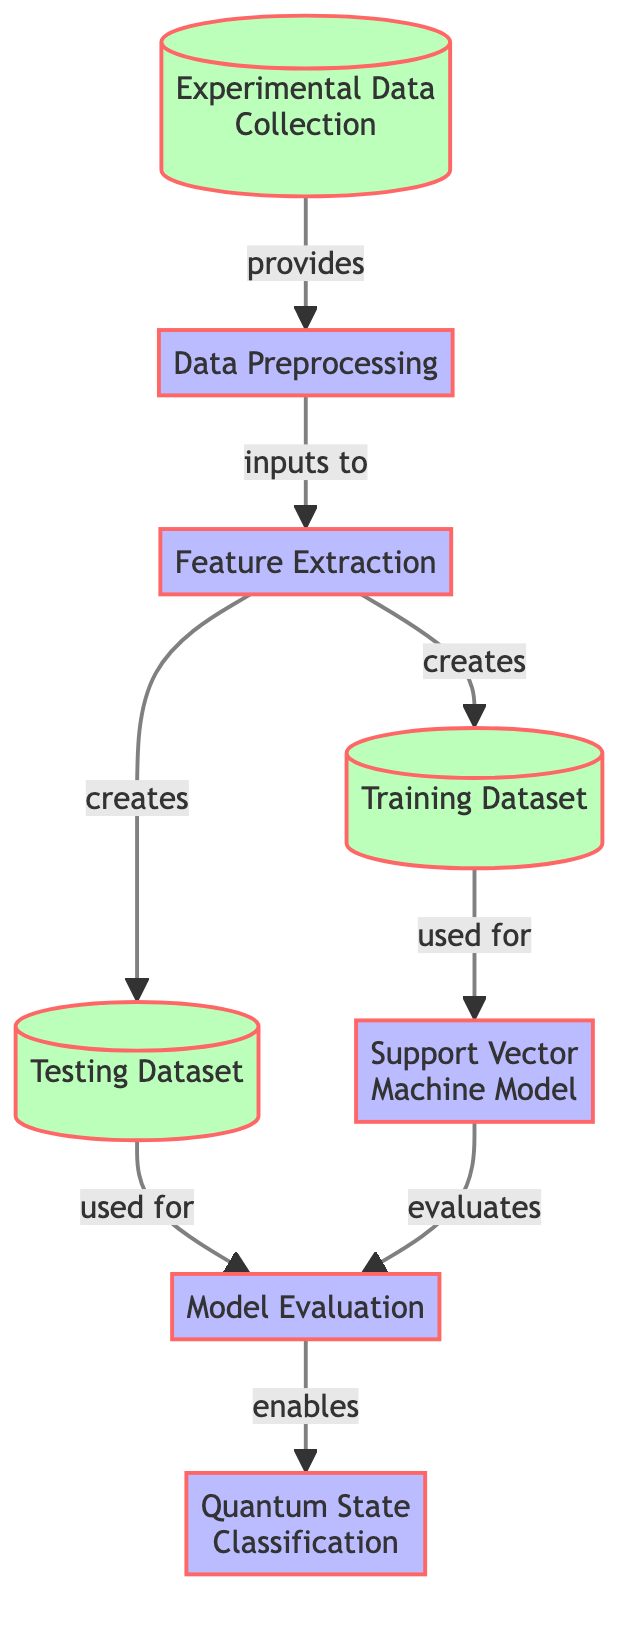What is the first step in the diagram? The first step, or node, in the diagram is "Experimental Data Collection." It is the starting point as indicated by its position at the top of the flowchart.
Answer: Experimental Data Collection How many processes are there in the diagram? By counting the nodes labeled as processes, we find there are four processes: "Data Preprocessing," "Feature Extraction," "Support Vector Machine Model," and "Model Evaluation."
Answer: Four What does the "Feature Extraction" node create? The "Feature Extraction" node has outgoing edges that lead to the "Training Dataset" and "Testing Dataset," indicating that it creates both of these outputs.
Answer: Training Dataset and Testing Dataset What is evaluated in the "Model Evaluation" step? The "Model Evaluation" step evaluates the "Support Vector Machine Model," as shown by the directed edge pointing from the model to the evaluation process.
Answer: Support Vector Machine Model Which node enables the "Quantum State Classification"? The "Model Evaluation" node enables the "Quantum State Classification," as indicated by the directional flow from the evaluation process to the classification step.
Answer: Model Evaluation What is the relationship between "Training Dataset" and "Support Vector Machine Model"? The "Training Dataset" is used for the "Support Vector Machine Model," as indicated by the directed edge that connects these two elements in the flowchart.
Answer: Used for What type of data is handled in the "Experimental Data Collection"? The "Experimental Data Collection" is gathering experimental data, which is the input material for further processing in the machine learning workflow depicted in the diagram.
Answer: Experimental Data How does the "Data Preprocessing" step relate to "Feature Extraction"? The "Data Preprocessing" step inputs data to the "Feature Extraction" process, meaning that preprocessed data is necessary for feature extraction to occur.
Answer: Inputs to Which output datasets are created by "Feature Extraction"? The "Feature Extraction" process generates two output datasets: "Training Dataset" and "Testing Dataset," as indicated by two outgoing connections from this node.
Answer: Training Dataset, Testing Dataset 